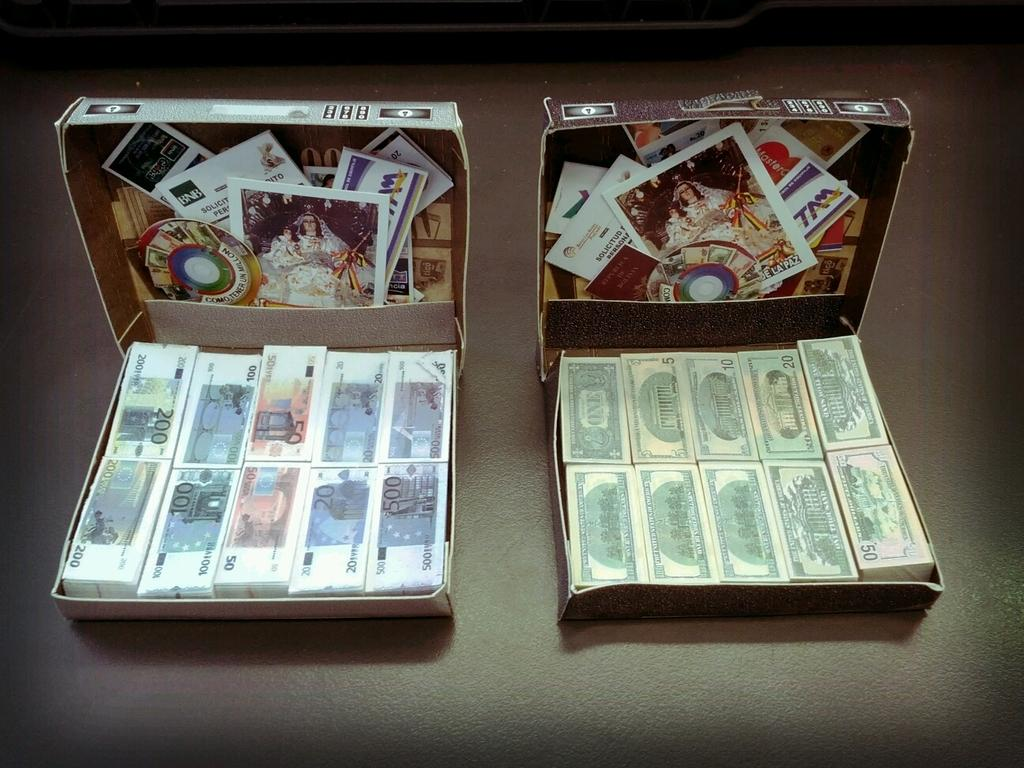<image>
Render a clear and concise summary of the photo. Several stacks of cash are in two seperate boxes, including denominations of 1, 5, 10, 20, 50, and 100. 